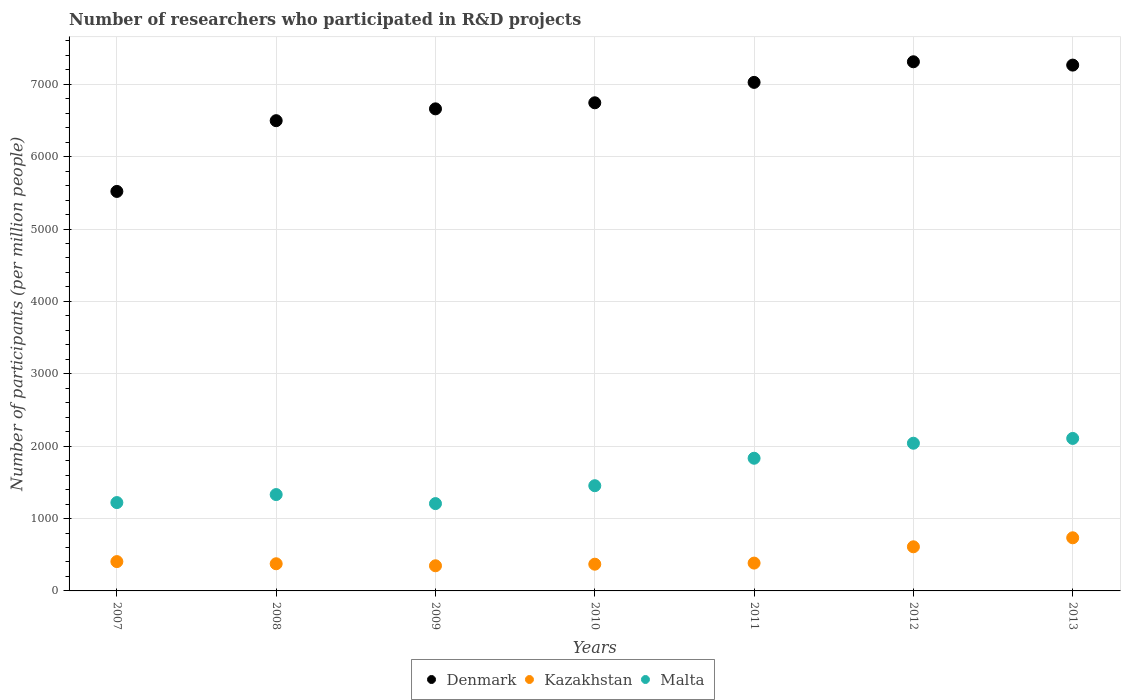Is the number of dotlines equal to the number of legend labels?
Give a very brief answer. Yes. What is the number of researchers who participated in R&D projects in Kazakhstan in 2007?
Provide a short and direct response. 405.2. Across all years, what is the maximum number of researchers who participated in R&D projects in Malta?
Offer a terse response. 2106.79. Across all years, what is the minimum number of researchers who participated in R&D projects in Kazakhstan?
Ensure brevity in your answer.  347.43. In which year was the number of researchers who participated in R&D projects in Malta minimum?
Your answer should be very brief. 2009. What is the total number of researchers who participated in R&D projects in Kazakhstan in the graph?
Your answer should be compact. 3225.18. What is the difference between the number of researchers who participated in R&D projects in Denmark in 2010 and that in 2013?
Your answer should be very brief. -520.66. What is the difference between the number of researchers who participated in R&D projects in Malta in 2013 and the number of researchers who participated in R&D projects in Denmark in 2010?
Make the answer very short. -4637.1. What is the average number of researchers who participated in R&D projects in Kazakhstan per year?
Offer a very short reply. 460.74. In the year 2008, what is the difference between the number of researchers who participated in R&D projects in Malta and number of researchers who participated in R&D projects in Kazakhstan?
Offer a very short reply. 956.01. In how many years, is the number of researchers who participated in R&D projects in Denmark greater than 3400?
Your answer should be very brief. 7. What is the ratio of the number of researchers who participated in R&D projects in Denmark in 2010 to that in 2013?
Your answer should be very brief. 0.93. Is the number of researchers who participated in R&D projects in Malta in 2009 less than that in 2010?
Keep it short and to the point. Yes. Is the difference between the number of researchers who participated in R&D projects in Malta in 2010 and 2013 greater than the difference between the number of researchers who participated in R&D projects in Kazakhstan in 2010 and 2013?
Provide a succinct answer. No. What is the difference between the highest and the second highest number of researchers who participated in R&D projects in Malta?
Ensure brevity in your answer.  66.35. What is the difference between the highest and the lowest number of researchers who participated in R&D projects in Kazakhstan?
Your response must be concise. 386.63. Is it the case that in every year, the sum of the number of researchers who participated in R&D projects in Kazakhstan and number of researchers who participated in R&D projects in Malta  is greater than the number of researchers who participated in R&D projects in Denmark?
Provide a succinct answer. No. Is the number of researchers who participated in R&D projects in Denmark strictly greater than the number of researchers who participated in R&D projects in Kazakhstan over the years?
Offer a very short reply. Yes. Is the number of researchers who participated in R&D projects in Denmark strictly less than the number of researchers who participated in R&D projects in Kazakhstan over the years?
Provide a succinct answer. No. How many dotlines are there?
Give a very brief answer. 3. How many years are there in the graph?
Offer a very short reply. 7. Are the values on the major ticks of Y-axis written in scientific E-notation?
Offer a terse response. No. Does the graph contain any zero values?
Your answer should be very brief. No. How many legend labels are there?
Provide a short and direct response. 3. What is the title of the graph?
Offer a very short reply. Number of researchers who participated in R&D projects. What is the label or title of the X-axis?
Ensure brevity in your answer.  Years. What is the label or title of the Y-axis?
Provide a succinct answer. Number of participants (per million people). What is the Number of participants (per million people) of Denmark in 2007?
Keep it short and to the point. 5519.32. What is the Number of participants (per million people) in Kazakhstan in 2007?
Provide a short and direct response. 405.2. What is the Number of participants (per million people) of Malta in 2007?
Keep it short and to the point. 1220.61. What is the Number of participants (per million people) in Denmark in 2008?
Offer a terse response. 6496.76. What is the Number of participants (per million people) of Kazakhstan in 2008?
Give a very brief answer. 375.22. What is the Number of participants (per million people) of Malta in 2008?
Keep it short and to the point. 1331.23. What is the Number of participants (per million people) of Denmark in 2009?
Provide a succinct answer. 6660.14. What is the Number of participants (per million people) of Kazakhstan in 2009?
Keep it short and to the point. 347.43. What is the Number of participants (per million people) in Malta in 2009?
Your answer should be compact. 1206.42. What is the Number of participants (per million people) of Denmark in 2010?
Provide a short and direct response. 6743.9. What is the Number of participants (per million people) of Kazakhstan in 2010?
Your response must be concise. 369.21. What is the Number of participants (per million people) of Malta in 2010?
Your answer should be very brief. 1453.66. What is the Number of participants (per million people) in Denmark in 2011?
Offer a terse response. 7025.82. What is the Number of participants (per million people) in Kazakhstan in 2011?
Provide a short and direct response. 384.43. What is the Number of participants (per million people) in Malta in 2011?
Your answer should be compact. 1833. What is the Number of participants (per million people) in Denmark in 2012?
Provide a succinct answer. 7310.52. What is the Number of participants (per million people) of Kazakhstan in 2012?
Provide a short and direct response. 609.64. What is the Number of participants (per million people) in Malta in 2012?
Provide a short and direct response. 2040.44. What is the Number of participants (per million people) of Denmark in 2013?
Give a very brief answer. 7264.56. What is the Number of participants (per million people) in Kazakhstan in 2013?
Keep it short and to the point. 734.05. What is the Number of participants (per million people) in Malta in 2013?
Offer a very short reply. 2106.79. Across all years, what is the maximum Number of participants (per million people) of Denmark?
Give a very brief answer. 7310.52. Across all years, what is the maximum Number of participants (per million people) of Kazakhstan?
Make the answer very short. 734.05. Across all years, what is the maximum Number of participants (per million people) in Malta?
Your response must be concise. 2106.79. Across all years, what is the minimum Number of participants (per million people) in Denmark?
Your answer should be very brief. 5519.32. Across all years, what is the minimum Number of participants (per million people) in Kazakhstan?
Provide a short and direct response. 347.43. Across all years, what is the minimum Number of participants (per million people) of Malta?
Provide a short and direct response. 1206.42. What is the total Number of participants (per million people) in Denmark in the graph?
Your answer should be compact. 4.70e+04. What is the total Number of participants (per million people) of Kazakhstan in the graph?
Your response must be concise. 3225.18. What is the total Number of participants (per million people) in Malta in the graph?
Offer a terse response. 1.12e+04. What is the difference between the Number of participants (per million people) of Denmark in 2007 and that in 2008?
Provide a succinct answer. -977.45. What is the difference between the Number of participants (per million people) of Kazakhstan in 2007 and that in 2008?
Make the answer very short. 29.98. What is the difference between the Number of participants (per million people) in Malta in 2007 and that in 2008?
Provide a succinct answer. -110.61. What is the difference between the Number of participants (per million people) in Denmark in 2007 and that in 2009?
Give a very brief answer. -1140.83. What is the difference between the Number of participants (per million people) of Kazakhstan in 2007 and that in 2009?
Give a very brief answer. 57.77. What is the difference between the Number of participants (per million people) of Malta in 2007 and that in 2009?
Provide a short and direct response. 14.19. What is the difference between the Number of participants (per million people) in Denmark in 2007 and that in 2010?
Your answer should be compact. -1224.58. What is the difference between the Number of participants (per million people) of Kazakhstan in 2007 and that in 2010?
Offer a very short reply. 35.99. What is the difference between the Number of participants (per million people) of Malta in 2007 and that in 2010?
Offer a terse response. -233.04. What is the difference between the Number of participants (per million people) in Denmark in 2007 and that in 2011?
Keep it short and to the point. -1506.5. What is the difference between the Number of participants (per million people) in Kazakhstan in 2007 and that in 2011?
Your response must be concise. 20.77. What is the difference between the Number of participants (per million people) of Malta in 2007 and that in 2011?
Offer a very short reply. -612.39. What is the difference between the Number of participants (per million people) of Denmark in 2007 and that in 2012?
Provide a short and direct response. -1791.2. What is the difference between the Number of participants (per million people) in Kazakhstan in 2007 and that in 2012?
Provide a short and direct response. -204.44. What is the difference between the Number of participants (per million people) of Malta in 2007 and that in 2012?
Provide a succinct answer. -819.83. What is the difference between the Number of participants (per million people) of Denmark in 2007 and that in 2013?
Provide a short and direct response. -1745.24. What is the difference between the Number of participants (per million people) of Kazakhstan in 2007 and that in 2013?
Give a very brief answer. -328.86. What is the difference between the Number of participants (per million people) in Malta in 2007 and that in 2013?
Your answer should be very brief. -886.18. What is the difference between the Number of participants (per million people) in Denmark in 2008 and that in 2009?
Ensure brevity in your answer.  -163.38. What is the difference between the Number of participants (per million people) of Kazakhstan in 2008 and that in 2009?
Offer a terse response. 27.79. What is the difference between the Number of participants (per million people) in Malta in 2008 and that in 2009?
Your answer should be very brief. 124.8. What is the difference between the Number of participants (per million people) in Denmark in 2008 and that in 2010?
Provide a succinct answer. -247.13. What is the difference between the Number of participants (per million people) in Kazakhstan in 2008 and that in 2010?
Your answer should be very brief. 6.01. What is the difference between the Number of participants (per million people) of Malta in 2008 and that in 2010?
Your answer should be very brief. -122.43. What is the difference between the Number of participants (per million people) of Denmark in 2008 and that in 2011?
Your answer should be compact. -529.05. What is the difference between the Number of participants (per million people) in Kazakhstan in 2008 and that in 2011?
Keep it short and to the point. -9.21. What is the difference between the Number of participants (per million people) of Malta in 2008 and that in 2011?
Your answer should be very brief. -501.77. What is the difference between the Number of participants (per million people) in Denmark in 2008 and that in 2012?
Make the answer very short. -813.75. What is the difference between the Number of participants (per million people) in Kazakhstan in 2008 and that in 2012?
Your answer should be compact. -234.42. What is the difference between the Number of participants (per million people) in Malta in 2008 and that in 2012?
Offer a very short reply. -709.22. What is the difference between the Number of participants (per million people) in Denmark in 2008 and that in 2013?
Provide a short and direct response. -767.79. What is the difference between the Number of participants (per million people) in Kazakhstan in 2008 and that in 2013?
Offer a terse response. -358.83. What is the difference between the Number of participants (per million people) in Malta in 2008 and that in 2013?
Give a very brief answer. -775.57. What is the difference between the Number of participants (per million people) in Denmark in 2009 and that in 2010?
Give a very brief answer. -83.75. What is the difference between the Number of participants (per million people) in Kazakhstan in 2009 and that in 2010?
Provide a short and direct response. -21.78. What is the difference between the Number of participants (per million people) in Malta in 2009 and that in 2010?
Your answer should be very brief. -247.23. What is the difference between the Number of participants (per million people) in Denmark in 2009 and that in 2011?
Provide a short and direct response. -365.67. What is the difference between the Number of participants (per million people) in Kazakhstan in 2009 and that in 2011?
Offer a very short reply. -37. What is the difference between the Number of participants (per million people) of Malta in 2009 and that in 2011?
Ensure brevity in your answer.  -626.58. What is the difference between the Number of participants (per million people) of Denmark in 2009 and that in 2012?
Offer a very short reply. -650.37. What is the difference between the Number of participants (per million people) of Kazakhstan in 2009 and that in 2012?
Provide a succinct answer. -262.21. What is the difference between the Number of participants (per million people) in Malta in 2009 and that in 2012?
Ensure brevity in your answer.  -834.02. What is the difference between the Number of participants (per million people) of Denmark in 2009 and that in 2013?
Offer a very short reply. -604.41. What is the difference between the Number of participants (per million people) in Kazakhstan in 2009 and that in 2013?
Your answer should be compact. -386.63. What is the difference between the Number of participants (per million people) in Malta in 2009 and that in 2013?
Your response must be concise. -900.37. What is the difference between the Number of participants (per million people) of Denmark in 2010 and that in 2011?
Your answer should be compact. -281.92. What is the difference between the Number of participants (per million people) in Kazakhstan in 2010 and that in 2011?
Give a very brief answer. -15.22. What is the difference between the Number of participants (per million people) of Malta in 2010 and that in 2011?
Keep it short and to the point. -379.34. What is the difference between the Number of participants (per million people) of Denmark in 2010 and that in 2012?
Give a very brief answer. -566.62. What is the difference between the Number of participants (per million people) in Kazakhstan in 2010 and that in 2012?
Ensure brevity in your answer.  -240.43. What is the difference between the Number of participants (per million people) in Malta in 2010 and that in 2012?
Offer a terse response. -586.79. What is the difference between the Number of participants (per million people) of Denmark in 2010 and that in 2013?
Keep it short and to the point. -520.66. What is the difference between the Number of participants (per million people) of Kazakhstan in 2010 and that in 2013?
Offer a terse response. -364.85. What is the difference between the Number of participants (per million people) in Malta in 2010 and that in 2013?
Your answer should be compact. -653.14. What is the difference between the Number of participants (per million people) in Denmark in 2011 and that in 2012?
Your answer should be compact. -284.7. What is the difference between the Number of participants (per million people) of Kazakhstan in 2011 and that in 2012?
Your answer should be compact. -225.21. What is the difference between the Number of participants (per million people) of Malta in 2011 and that in 2012?
Keep it short and to the point. -207.44. What is the difference between the Number of participants (per million people) of Denmark in 2011 and that in 2013?
Your answer should be very brief. -238.74. What is the difference between the Number of participants (per million people) in Kazakhstan in 2011 and that in 2013?
Ensure brevity in your answer.  -349.62. What is the difference between the Number of participants (per million people) in Malta in 2011 and that in 2013?
Your answer should be very brief. -273.79. What is the difference between the Number of participants (per million people) in Denmark in 2012 and that in 2013?
Give a very brief answer. 45.96. What is the difference between the Number of participants (per million people) in Kazakhstan in 2012 and that in 2013?
Keep it short and to the point. -124.42. What is the difference between the Number of participants (per million people) in Malta in 2012 and that in 2013?
Your answer should be very brief. -66.35. What is the difference between the Number of participants (per million people) of Denmark in 2007 and the Number of participants (per million people) of Kazakhstan in 2008?
Make the answer very short. 5144.09. What is the difference between the Number of participants (per million people) in Denmark in 2007 and the Number of participants (per million people) in Malta in 2008?
Provide a short and direct response. 4188.09. What is the difference between the Number of participants (per million people) of Kazakhstan in 2007 and the Number of participants (per million people) of Malta in 2008?
Offer a terse response. -926.03. What is the difference between the Number of participants (per million people) in Denmark in 2007 and the Number of participants (per million people) in Kazakhstan in 2009?
Provide a succinct answer. 5171.89. What is the difference between the Number of participants (per million people) in Denmark in 2007 and the Number of participants (per million people) in Malta in 2009?
Offer a very short reply. 4312.89. What is the difference between the Number of participants (per million people) in Kazakhstan in 2007 and the Number of participants (per million people) in Malta in 2009?
Make the answer very short. -801.22. What is the difference between the Number of participants (per million people) of Denmark in 2007 and the Number of participants (per million people) of Kazakhstan in 2010?
Your answer should be very brief. 5150.11. What is the difference between the Number of participants (per million people) of Denmark in 2007 and the Number of participants (per million people) of Malta in 2010?
Provide a succinct answer. 4065.66. What is the difference between the Number of participants (per million people) of Kazakhstan in 2007 and the Number of participants (per million people) of Malta in 2010?
Provide a short and direct response. -1048.46. What is the difference between the Number of participants (per million people) of Denmark in 2007 and the Number of participants (per million people) of Kazakhstan in 2011?
Your answer should be very brief. 5134.88. What is the difference between the Number of participants (per million people) of Denmark in 2007 and the Number of participants (per million people) of Malta in 2011?
Your answer should be compact. 3686.31. What is the difference between the Number of participants (per million people) in Kazakhstan in 2007 and the Number of participants (per million people) in Malta in 2011?
Offer a very short reply. -1427.8. What is the difference between the Number of participants (per million people) in Denmark in 2007 and the Number of participants (per million people) in Kazakhstan in 2012?
Keep it short and to the point. 4909.68. What is the difference between the Number of participants (per million people) of Denmark in 2007 and the Number of participants (per million people) of Malta in 2012?
Your answer should be compact. 3478.87. What is the difference between the Number of participants (per million people) in Kazakhstan in 2007 and the Number of participants (per million people) in Malta in 2012?
Offer a terse response. -1635.24. What is the difference between the Number of participants (per million people) of Denmark in 2007 and the Number of participants (per million people) of Kazakhstan in 2013?
Provide a short and direct response. 4785.26. What is the difference between the Number of participants (per million people) in Denmark in 2007 and the Number of participants (per million people) in Malta in 2013?
Make the answer very short. 3412.52. What is the difference between the Number of participants (per million people) of Kazakhstan in 2007 and the Number of participants (per million people) of Malta in 2013?
Offer a very short reply. -1701.6. What is the difference between the Number of participants (per million people) in Denmark in 2008 and the Number of participants (per million people) in Kazakhstan in 2009?
Provide a short and direct response. 6149.34. What is the difference between the Number of participants (per million people) in Denmark in 2008 and the Number of participants (per million people) in Malta in 2009?
Provide a short and direct response. 5290.34. What is the difference between the Number of participants (per million people) of Kazakhstan in 2008 and the Number of participants (per million people) of Malta in 2009?
Offer a terse response. -831.2. What is the difference between the Number of participants (per million people) of Denmark in 2008 and the Number of participants (per million people) of Kazakhstan in 2010?
Make the answer very short. 6127.56. What is the difference between the Number of participants (per million people) of Denmark in 2008 and the Number of participants (per million people) of Malta in 2010?
Provide a succinct answer. 5043.11. What is the difference between the Number of participants (per million people) in Kazakhstan in 2008 and the Number of participants (per million people) in Malta in 2010?
Provide a succinct answer. -1078.44. What is the difference between the Number of participants (per million people) in Denmark in 2008 and the Number of participants (per million people) in Kazakhstan in 2011?
Your answer should be very brief. 6112.33. What is the difference between the Number of participants (per million people) in Denmark in 2008 and the Number of participants (per million people) in Malta in 2011?
Offer a terse response. 4663.76. What is the difference between the Number of participants (per million people) in Kazakhstan in 2008 and the Number of participants (per million people) in Malta in 2011?
Provide a succinct answer. -1457.78. What is the difference between the Number of participants (per million people) in Denmark in 2008 and the Number of participants (per million people) in Kazakhstan in 2012?
Your response must be concise. 5887.13. What is the difference between the Number of participants (per million people) in Denmark in 2008 and the Number of participants (per million people) in Malta in 2012?
Provide a succinct answer. 4456.32. What is the difference between the Number of participants (per million people) in Kazakhstan in 2008 and the Number of participants (per million people) in Malta in 2012?
Provide a short and direct response. -1665.22. What is the difference between the Number of participants (per million people) of Denmark in 2008 and the Number of participants (per million people) of Kazakhstan in 2013?
Offer a terse response. 5762.71. What is the difference between the Number of participants (per million people) in Denmark in 2008 and the Number of participants (per million people) in Malta in 2013?
Ensure brevity in your answer.  4389.97. What is the difference between the Number of participants (per million people) of Kazakhstan in 2008 and the Number of participants (per million people) of Malta in 2013?
Keep it short and to the point. -1731.57. What is the difference between the Number of participants (per million people) in Denmark in 2009 and the Number of participants (per million people) in Kazakhstan in 2010?
Provide a succinct answer. 6290.94. What is the difference between the Number of participants (per million people) of Denmark in 2009 and the Number of participants (per million people) of Malta in 2010?
Provide a short and direct response. 5206.49. What is the difference between the Number of participants (per million people) in Kazakhstan in 2009 and the Number of participants (per million people) in Malta in 2010?
Your answer should be very brief. -1106.23. What is the difference between the Number of participants (per million people) in Denmark in 2009 and the Number of participants (per million people) in Kazakhstan in 2011?
Offer a terse response. 6275.71. What is the difference between the Number of participants (per million people) in Denmark in 2009 and the Number of participants (per million people) in Malta in 2011?
Offer a terse response. 4827.14. What is the difference between the Number of participants (per million people) in Kazakhstan in 2009 and the Number of participants (per million people) in Malta in 2011?
Ensure brevity in your answer.  -1485.57. What is the difference between the Number of participants (per million people) in Denmark in 2009 and the Number of participants (per million people) in Kazakhstan in 2012?
Offer a very short reply. 6050.51. What is the difference between the Number of participants (per million people) of Denmark in 2009 and the Number of participants (per million people) of Malta in 2012?
Your response must be concise. 4619.7. What is the difference between the Number of participants (per million people) of Kazakhstan in 2009 and the Number of participants (per million people) of Malta in 2012?
Your response must be concise. -1693.02. What is the difference between the Number of participants (per million people) of Denmark in 2009 and the Number of participants (per million people) of Kazakhstan in 2013?
Make the answer very short. 5926.09. What is the difference between the Number of participants (per million people) of Denmark in 2009 and the Number of participants (per million people) of Malta in 2013?
Provide a short and direct response. 4553.35. What is the difference between the Number of participants (per million people) in Kazakhstan in 2009 and the Number of participants (per million people) in Malta in 2013?
Give a very brief answer. -1759.37. What is the difference between the Number of participants (per million people) of Denmark in 2010 and the Number of participants (per million people) of Kazakhstan in 2011?
Provide a short and direct response. 6359.47. What is the difference between the Number of participants (per million people) in Denmark in 2010 and the Number of participants (per million people) in Malta in 2011?
Provide a succinct answer. 4910.9. What is the difference between the Number of participants (per million people) of Kazakhstan in 2010 and the Number of participants (per million people) of Malta in 2011?
Offer a terse response. -1463.79. What is the difference between the Number of participants (per million people) in Denmark in 2010 and the Number of participants (per million people) in Kazakhstan in 2012?
Make the answer very short. 6134.26. What is the difference between the Number of participants (per million people) in Denmark in 2010 and the Number of participants (per million people) in Malta in 2012?
Give a very brief answer. 4703.45. What is the difference between the Number of participants (per million people) of Kazakhstan in 2010 and the Number of participants (per million people) of Malta in 2012?
Your response must be concise. -1671.24. What is the difference between the Number of participants (per million people) in Denmark in 2010 and the Number of participants (per million people) in Kazakhstan in 2013?
Offer a very short reply. 6009.84. What is the difference between the Number of participants (per million people) in Denmark in 2010 and the Number of participants (per million people) in Malta in 2013?
Ensure brevity in your answer.  4637.1. What is the difference between the Number of participants (per million people) in Kazakhstan in 2010 and the Number of participants (per million people) in Malta in 2013?
Provide a short and direct response. -1737.59. What is the difference between the Number of participants (per million people) of Denmark in 2011 and the Number of participants (per million people) of Kazakhstan in 2012?
Your answer should be compact. 6416.18. What is the difference between the Number of participants (per million people) of Denmark in 2011 and the Number of participants (per million people) of Malta in 2012?
Provide a short and direct response. 4985.37. What is the difference between the Number of participants (per million people) of Kazakhstan in 2011 and the Number of participants (per million people) of Malta in 2012?
Give a very brief answer. -1656.01. What is the difference between the Number of participants (per million people) in Denmark in 2011 and the Number of participants (per million people) in Kazakhstan in 2013?
Keep it short and to the point. 6291.76. What is the difference between the Number of participants (per million people) in Denmark in 2011 and the Number of participants (per million people) in Malta in 2013?
Provide a short and direct response. 4919.02. What is the difference between the Number of participants (per million people) in Kazakhstan in 2011 and the Number of participants (per million people) in Malta in 2013?
Offer a very short reply. -1722.36. What is the difference between the Number of participants (per million people) in Denmark in 2012 and the Number of participants (per million people) in Kazakhstan in 2013?
Give a very brief answer. 6576.46. What is the difference between the Number of participants (per million people) of Denmark in 2012 and the Number of participants (per million people) of Malta in 2013?
Keep it short and to the point. 5203.72. What is the difference between the Number of participants (per million people) in Kazakhstan in 2012 and the Number of participants (per million people) in Malta in 2013?
Ensure brevity in your answer.  -1497.16. What is the average Number of participants (per million people) in Denmark per year?
Offer a very short reply. 6717.29. What is the average Number of participants (per million people) of Kazakhstan per year?
Provide a succinct answer. 460.74. What is the average Number of participants (per million people) in Malta per year?
Provide a succinct answer. 1598.88. In the year 2007, what is the difference between the Number of participants (per million people) of Denmark and Number of participants (per million people) of Kazakhstan?
Offer a terse response. 5114.12. In the year 2007, what is the difference between the Number of participants (per million people) of Denmark and Number of participants (per million people) of Malta?
Offer a terse response. 4298.7. In the year 2007, what is the difference between the Number of participants (per million people) of Kazakhstan and Number of participants (per million people) of Malta?
Your response must be concise. -815.41. In the year 2008, what is the difference between the Number of participants (per million people) in Denmark and Number of participants (per million people) in Kazakhstan?
Offer a terse response. 6121.54. In the year 2008, what is the difference between the Number of participants (per million people) in Denmark and Number of participants (per million people) in Malta?
Offer a very short reply. 5165.54. In the year 2008, what is the difference between the Number of participants (per million people) in Kazakhstan and Number of participants (per million people) in Malta?
Your answer should be compact. -956.01. In the year 2009, what is the difference between the Number of participants (per million people) in Denmark and Number of participants (per million people) in Kazakhstan?
Offer a terse response. 6312.72. In the year 2009, what is the difference between the Number of participants (per million people) in Denmark and Number of participants (per million people) in Malta?
Keep it short and to the point. 5453.72. In the year 2009, what is the difference between the Number of participants (per million people) of Kazakhstan and Number of participants (per million people) of Malta?
Ensure brevity in your answer.  -859. In the year 2010, what is the difference between the Number of participants (per million people) in Denmark and Number of participants (per million people) in Kazakhstan?
Provide a short and direct response. 6374.69. In the year 2010, what is the difference between the Number of participants (per million people) in Denmark and Number of participants (per million people) in Malta?
Ensure brevity in your answer.  5290.24. In the year 2010, what is the difference between the Number of participants (per million people) of Kazakhstan and Number of participants (per million people) of Malta?
Provide a succinct answer. -1084.45. In the year 2011, what is the difference between the Number of participants (per million people) in Denmark and Number of participants (per million people) in Kazakhstan?
Offer a very short reply. 6641.38. In the year 2011, what is the difference between the Number of participants (per million people) in Denmark and Number of participants (per million people) in Malta?
Give a very brief answer. 5192.81. In the year 2011, what is the difference between the Number of participants (per million people) of Kazakhstan and Number of participants (per million people) of Malta?
Offer a very short reply. -1448.57. In the year 2012, what is the difference between the Number of participants (per million people) in Denmark and Number of participants (per million people) in Kazakhstan?
Give a very brief answer. 6700.88. In the year 2012, what is the difference between the Number of participants (per million people) of Denmark and Number of participants (per million people) of Malta?
Offer a terse response. 5270.07. In the year 2012, what is the difference between the Number of participants (per million people) in Kazakhstan and Number of participants (per million people) in Malta?
Ensure brevity in your answer.  -1430.81. In the year 2013, what is the difference between the Number of participants (per million people) in Denmark and Number of participants (per million people) in Kazakhstan?
Your answer should be compact. 6530.5. In the year 2013, what is the difference between the Number of participants (per million people) of Denmark and Number of participants (per million people) of Malta?
Make the answer very short. 5157.76. In the year 2013, what is the difference between the Number of participants (per million people) of Kazakhstan and Number of participants (per million people) of Malta?
Give a very brief answer. -1372.74. What is the ratio of the Number of participants (per million people) of Denmark in 2007 to that in 2008?
Provide a short and direct response. 0.85. What is the ratio of the Number of participants (per million people) in Kazakhstan in 2007 to that in 2008?
Keep it short and to the point. 1.08. What is the ratio of the Number of participants (per million people) of Malta in 2007 to that in 2008?
Ensure brevity in your answer.  0.92. What is the ratio of the Number of participants (per million people) of Denmark in 2007 to that in 2009?
Provide a short and direct response. 0.83. What is the ratio of the Number of participants (per million people) in Kazakhstan in 2007 to that in 2009?
Provide a succinct answer. 1.17. What is the ratio of the Number of participants (per million people) of Malta in 2007 to that in 2009?
Your answer should be very brief. 1.01. What is the ratio of the Number of participants (per million people) in Denmark in 2007 to that in 2010?
Offer a terse response. 0.82. What is the ratio of the Number of participants (per million people) in Kazakhstan in 2007 to that in 2010?
Offer a terse response. 1.1. What is the ratio of the Number of participants (per million people) of Malta in 2007 to that in 2010?
Keep it short and to the point. 0.84. What is the ratio of the Number of participants (per million people) of Denmark in 2007 to that in 2011?
Provide a short and direct response. 0.79. What is the ratio of the Number of participants (per million people) in Kazakhstan in 2007 to that in 2011?
Your answer should be compact. 1.05. What is the ratio of the Number of participants (per million people) in Malta in 2007 to that in 2011?
Offer a very short reply. 0.67. What is the ratio of the Number of participants (per million people) of Denmark in 2007 to that in 2012?
Provide a succinct answer. 0.76. What is the ratio of the Number of participants (per million people) of Kazakhstan in 2007 to that in 2012?
Your answer should be compact. 0.66. What is the ratio of the Number of participants (per million people) in Malta in 2007 to that in 2012?
Provide a succinct answer. 0.6. What is the ratio of the Number of participants (per million people) in Denmark in 2007 to that in 2013?
Make the answer very short. 0.76. What is the ratio of the Number of participants (per million people) in Kazakhstan in 2007 to that in 2013?
Offer a terse response. 0.55. What is the ratio of the Number of participants (per million people) in Malta in 2007 to that in 2013?
Your response must be concise. 0.58. What is the ratio of the Number of participants (per million people) of Denmark in 2008 to that in 2009?
Provide a short and direct response. 0.98. What is the ratio of the Number of participants (per million people) of Malta in 2008 to that in 2009?
Make the answer very short. 1.1. What is the ratio of the Number of participants (per million people) in Denmark in 2008 to that in 2010?
Provide a short and direct response. 0.96. What is the ratio of the Number of participants (per million people) of Kazakhstan in 2008 to that in 2010?
Give a very brief answer. 1.02. What is the ratio of the Number of participants (per million people) in Malta in 2008 to that in 2010?
Keep it short and to the point. 0.92. What is the ratio of the Number of participants (per million people) of Denmark in 2008 to that in 2011?
Make the answer very short. 0.92. What is the ratio of the Number of participants (per million people) in Kazakhstan in 2008 to that in 2011?
Make the answer very short. 0.98. What is the ratio of the Number of participants (per million people) of Malta in 2008 to that in 2011?
Keep it short and to the point. 0.73. What is the ratio of the Number of participants (per million people) in Denmark in 2008 to that in 2012?
Make the answer very short. 0.89. What is the ratio of the Number of participants (per million people) in Kazakhstan in 2008 to that in 2012?
Offer a terse response. 0.62. What is the ratio of the Number of participants (per million people) in Malta in 2008 to that in 2012?
Your response must be concise. 0.65. What is the ratio of the Number of participants (per million people) of Denmark in 2008 to that in 2013?
Ensure brevity in your answer.  0.89. What is the ratio of the Number of participants (per million people) in Kazakhstan in 2008 to that in 2013?
Your answer should be compact. 0.51. What is the ratio of the Number of participants (per million people) of Malta in 2008 to that in 2013?
Keep it short and to the point. 0.63. What is the ratio of the Number of participants (per million people) of Denmark in 2009 to that in 2010?
Keep it short and to the point. 0.99. What is the ratio of the Number of participants (per million people) in Kazakhstan in 2009 to that in 2010?
Ensure brevity in your answer.  0.94. What is the ratio of the Number of participants (per million people) in Malta in 2009 to that in 2010?
Make the answer very short. 0.83. What is the ratio of the Number of participants (per million people) of Denmark in 2009 to that in 2011?
Make the answer very short. 0.95. What is the ratio of the Number of participants (per million people) of Kazakhstan in 2009 to that in 2011?
Offer a very short reply. 0.9. What is the ratio of the Number of participants (per million people) of Malta in 2009 to that in 2011?
Ensure brevity in your answer.  0.66. What is the ratio of the Number of participants (per million people) of Denmark in 2009 to that in 2012?
Ensure brevity in your answer.  0.91. What is the ratio of the Number of participants (per million people) of Kazakhstan in 2009 to that in 2012?
Your answer should be very brief. 0.57. What is the ratio of the Number of participants (per million people) of Malta in 2009 to that in 2012?
Your response must be concise. 0.59. What is the ratio of the Number of participants (per million people) in Denmark in 2009 to that in 2013?
Ensure brevity in your answer.  0.92. What is the ratio of the Number of participants (per million people) of Kazakhstan in 2009 to that in 2013?
Your answer should be compact. 0.47. What is the ratio of the Number of participants (per million people) of Malta in 2009 to that in 2013?
Keep it short and to the point. 0.57. What is the ratio of the Number of participants (per million people) in Denmark in 2010 to that in 2011?
Your answer should be very brief. 0.96. What is the ratio of the Number of participants (per million people) of Kazakhstan in 2010 to that in 2011?
Make the answer very short. 0.96. What is the ratio of the Number of participants (per million people) in Malta in 2010 to that in 2011?
Make the answer very short. 0.79. What is the ratio of the Number of participants (per million people) in Denmark in 2010 to that in 2012?
Offer a terse response. 0.92. What is the ratio of the Number of participants (per million people) of Kazakhstan in 2010 to that in 2012?
Ensure brevity in your answer.  0.61. What is the ratio of the Number of participants (per million people) in Malta in 2010 to that in 2012?
Provide a succinct answer. 0.71. What is the ratio of the Number of participants (per million people) in Denmark in 2010 to that in 2013?
Your answer should be compact. 0.93. What is the ratio of the Number of participants (per million people) in Kazakhstan in 2010 to that in 2013?
Offer a very short reply. 0.5. What is the ratio of the Number of participants (per million people) in Malta in 2010 to that in 2013?
Give a very brief answer. 0.69. What is the ratio of the Number of participants (per million people) in Denmark in 2011 to that in 2012?
Your answer should be compact. 0.96. What is the ratio of the Number of participants (per million people) of Kazakhstan in 2011 to that in 2012?
Keep it short and to the point. 0.63. What is the ratio of the Number of participants (per million people) of Malta in 2011 to that in 2012?
Your answer should be very brief. 0.9. What is the ratio of the Number of participants (per million people) of Denmark in 2011 to that in 2013?
Give a very brief answer. 0.97. What is the ratio of the Number of participants (per million people) in Kazakhstan in 2011 to that in 2013?
Your answer should be compact. 0.52. What is the ratio of the Number of participants (per million people) of Malta in 2011 to that in 2013?
Provide a short and direct response. 0.87. What is the ratio of the Number of participants (per million people) in Kazakhstan in 2012 to that in 2013?
Offer a very short reply. 0.83. What is the ratio of the Number of participants (per million people) in Malta in 2012 to that in 2013?
Offer a very short reply. 0.97. What is the difference between the highest and the second highest Number of participants (per million people) of Denmark?
Your answer should be compact. 45.96. What is the difference between the highest and the second highest Number of participants (per million people) in Kazakhstan?
Ensure brevity in your answer.  124.42. What is the difference between the highest and the second highest Number of participants (per million people) of Malta?
Your response must be concise. 66.35. What is the difference between the highest and the lowest Number of participants (per million people) in Denmark?
Provide a succinct answer. 1791.2. What is the difference between the highest and the lowest Number of participants (per million people) of Kazakhstan?
Your answer should be very brief. 386.63. What is the difference between the highest and the lowest Number of participants (per million people) of Malta?
Offer a terse response. 900.37. 